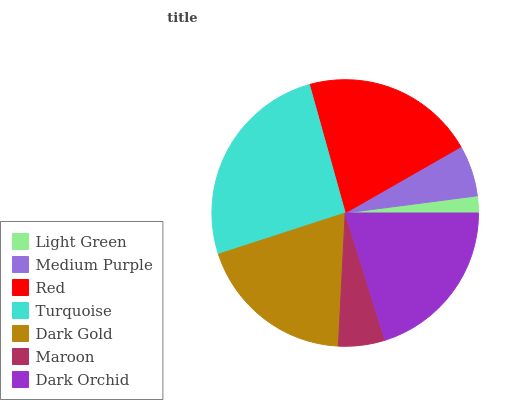Is Light Green the minimum?
Answer yes or no. Yes. Is Turquoise the maximum?
Answer yes or no. Yes. Is Medium Purple the minimum?
Answer yes or no. No. Is Medium Purple the maximum?
Answer yes or no. No. Is Medium Purple greater than Light Green?
Answer yes or no. Yes. Is Light Green less than Medium Purple?
Answer yes or no. Yes. Is Light Green greater than Medium Purple?
Answer yes or no. No. Is Medium Purple less than Light Green?
Answer yes or no. No. Is Dark Gold the high median?
Answer yes or no. Yes. Is Dark Gold the low median?
Answer yes or no. Yes. Is Light Green the high median?
Answer yes or no. No. Is Medium Purple the low median?
Answer yes or no. No. 